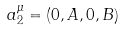<formula> <loc_0><loc_0><loc_500><loc_500>a ^ { \mu } _ { 2 } = ( 0 , A , 0 , B )</formula> 